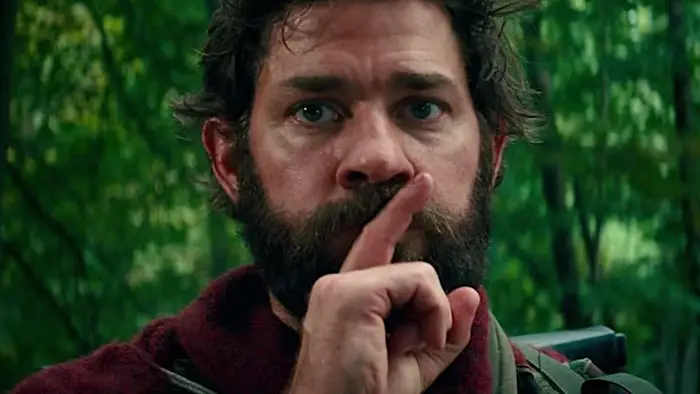What do you see happening in this image? The image portrays a man with a thick beard in a red jacket, making a shushing gesture with his finger pressed to his lips. He appears to be in a forested area, and his serious expression combined with the intense look in his eyes suggests he is in a tense or perilous situation. This gesture typically denotes the need for silence, possibly hinting at an attempt to evade detection or handle a dangerous situation discreetly. 